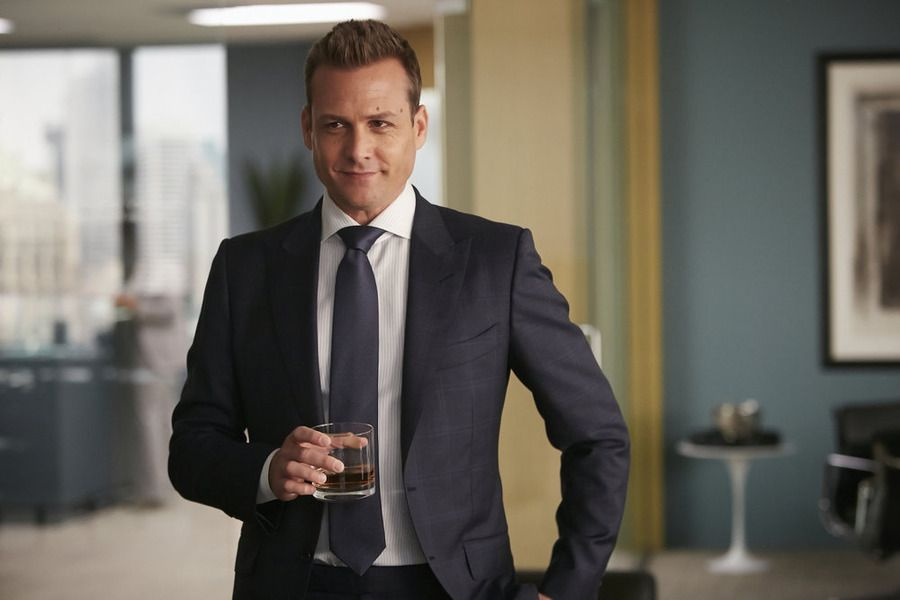Can you create a poetic description of this scene? In a tower high above the urban sprawl,\nA figure stands, a master of it all.\nDraped in twilight's gentle, cooling hue,\nHe gazes out, to skies of deepening blue.\n\nA suit of night, crisp lines so tailored neat,\nIn hand, a crystal glass, with amber heat.\nThe city murmurs softly in the night,\nAnd windows frame a world, both bold and bright.\n\nWithin his office, whispers of success,\nA realm of power, calm and poise confess.\nYet shadows play where light and dark converge,\nIn silent dialogue, where visions surge. 